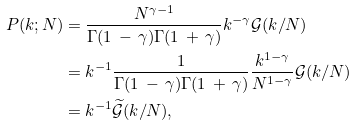Convert formula to latex. <formula><loc_0><loc_0><loc_500><loc_500>P ( k ; N ) & = \frac { N ^ { \gamma - 1 } } { \Gamma ( 1 \, - \, \gamma ) \Gamma ( 1 \, + \, \gamma ) } k ^ { - \gamma } \mathcal { G } ( k / N ) \\ & = k ^ { - 1 } \frac { 1 } { \Gamma ( 1 \, - \, \gamma ) \Gamma ( 1 \, + \, \gamma ) } \frac { k ^ { 1 - \gamma } } { N ^ { 1 - \gamma } } \mathcal { G } ( k / N ) \\ & = k ^ { - 1 } \widetilde { \mathcal { G } } ( k / N ) ,</formula> 